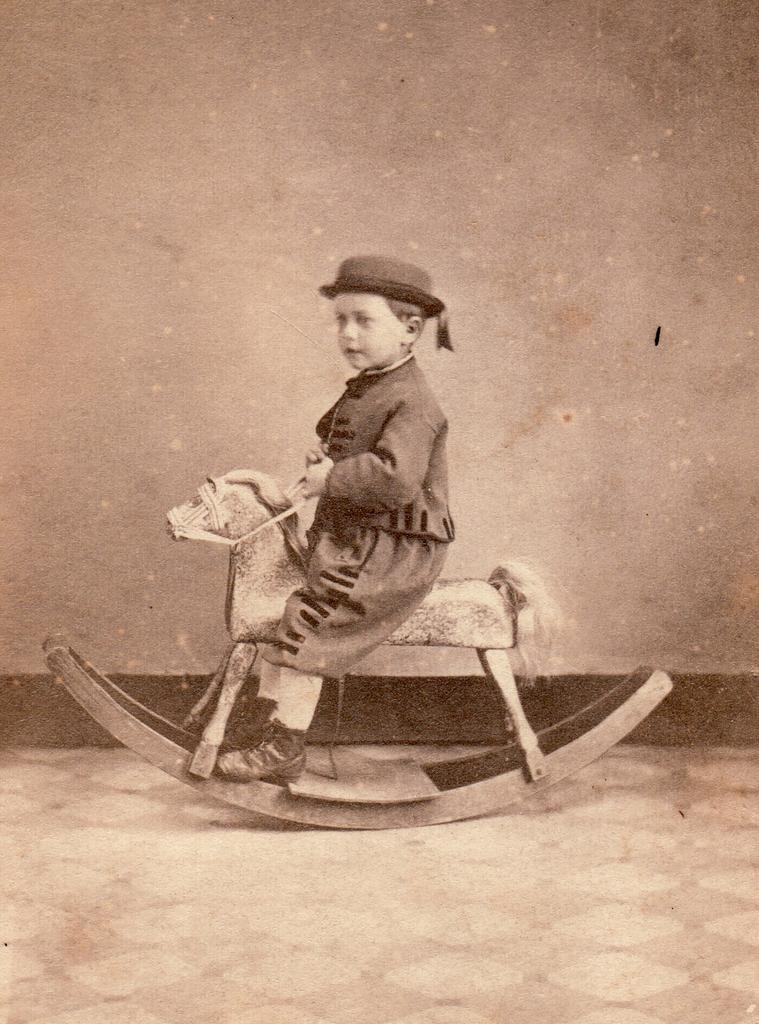Who is the main subject in the image? There is a boy in the image. What is the boy doing in the image? The boy is sitting on a toy. What can be seen behind the boy? There is a wall behind the boy. What is the surface on which the boy and the toy are placed? There is a floor visible at the bottom of the image. How many icicles are hanging from the lamp in the image? There is no lamp or icicles present in the image. 